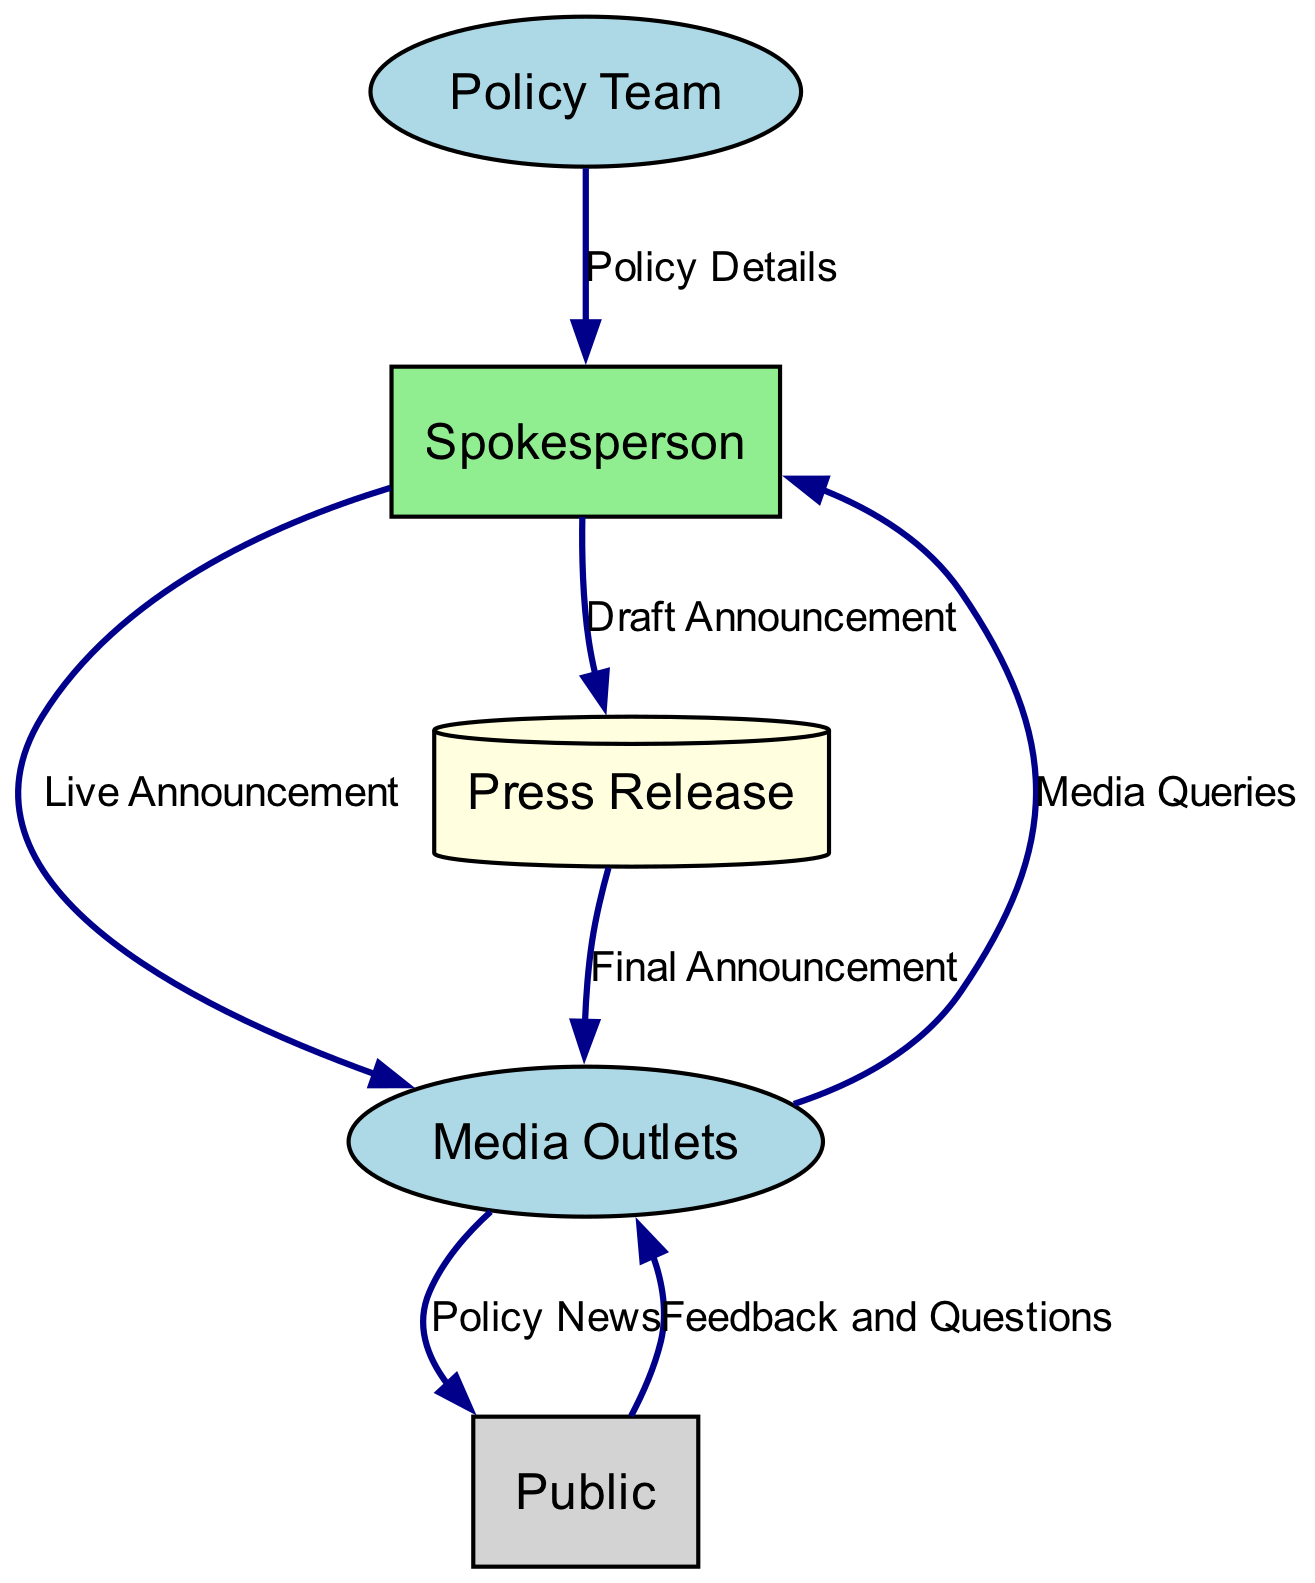What is the external entity responsible for creating the policy? The "Policy Team" is noted in the diagram as the entity responsible for crafting the policy and supplying details for the announcement.
Answer: Policy Team How many processes are represented in the diagram? Upon reviewing the diagram, it can be observed that there is only one process detailed, which is the "Spokesperson."
Answer: 1 Which data flow connects the Spokesperson to the Press Release? The flow labeled "Draft Announcement" connects the Spokesperson to the Press Release, depicting how the Spokesperson sends the initial draft of the announcement.
Answer: Draft Announcement What type of node is the Press Release? The Press Release is identified as a Data Store within the diagram, representing it as a repository for storing policy announcement details.
Answer: Data Store What data flows from Media Outlets to Public? The data flow is titled "Policy News," indicating the information shared by media outlets with the public regarding the policy announcement.
Answer: Policy News Which node does the Media Outlets send feedback and questions to? The Media Outlets send "Feedback and Questions" to the Spokesperson, indicating that public responses regarding the policy are directed back to them.
Answer: Spokesperson What does the Spokesperson communicate to the Media Outlets during the engagement process? The Spokesperson provides a "Live Announcement," which signifies direct communication or briefing to the media regarding the policy.
Answer: Live Announcement What type of connection exists between the Policy Team and the Spokesperson? The connection is a data flow labeled "Policy Details," indicating the flow of comprehensive policy information from the Policy Team to the Spokesperson.
Answer: Policy Details How many external entities are included in the workflow? The diagram identifies two external entities involved in the workflow: the Policy Team and Media Outlets.
Answer: 2 